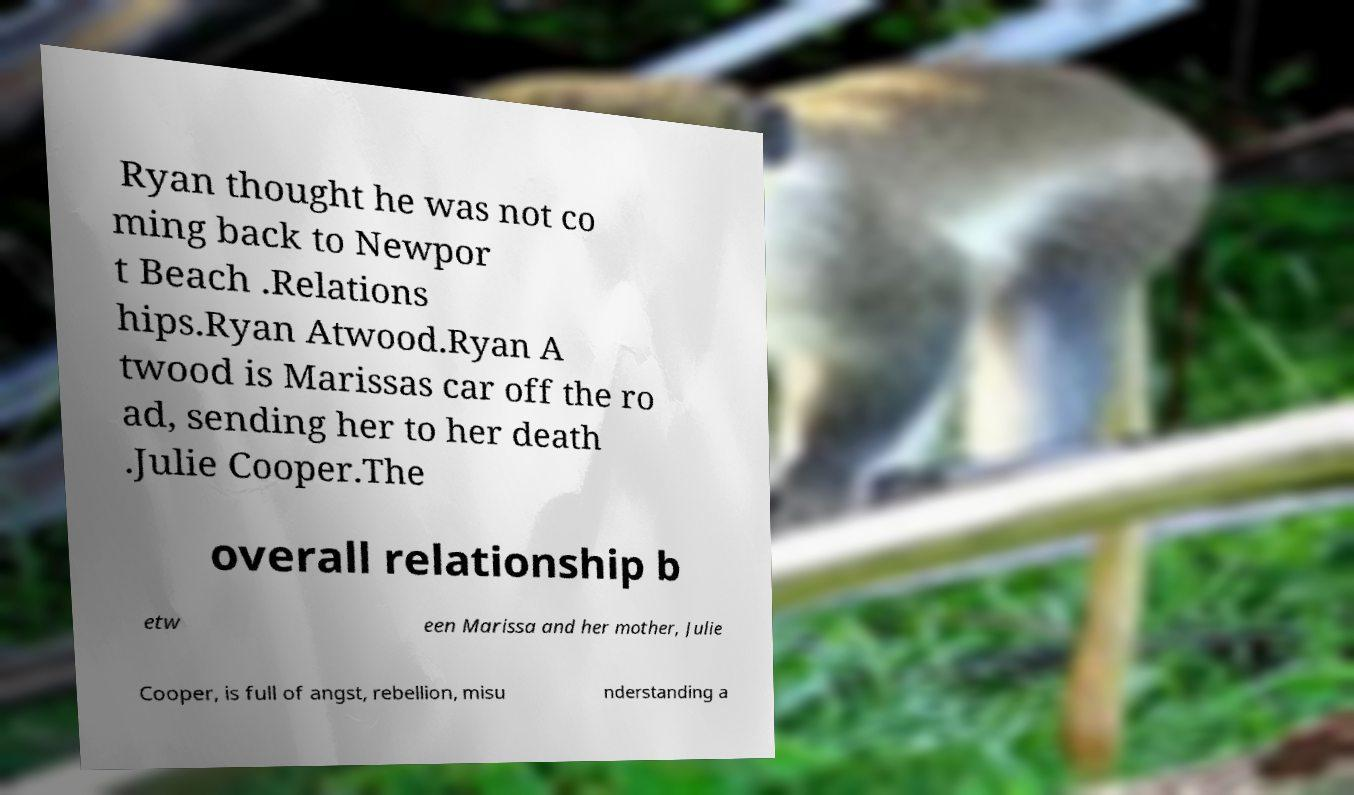There's text embedded in this image that I need extracted. Can you transcribe it verbatim? Ryan thought he was not co ming back to Newpor t Beach .Relations hips.Ryan Atwood.Ryan A twood is Marissas car off the ro ad, sending her to her death .Julie Cooper.The overall relationship b etw een Marissa and her mother, Julie Cooper, is full of angst, rebellion, misu nderstanding a 